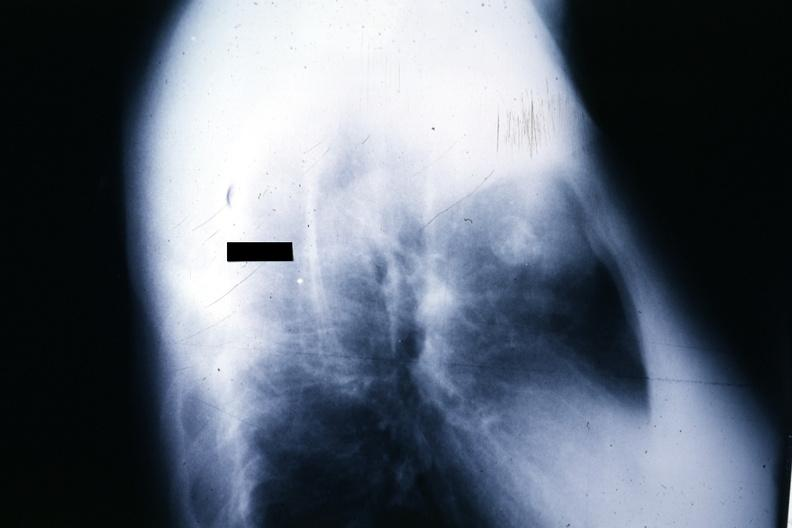what is present?
Answer the question using a single word or phrase. Thymus 